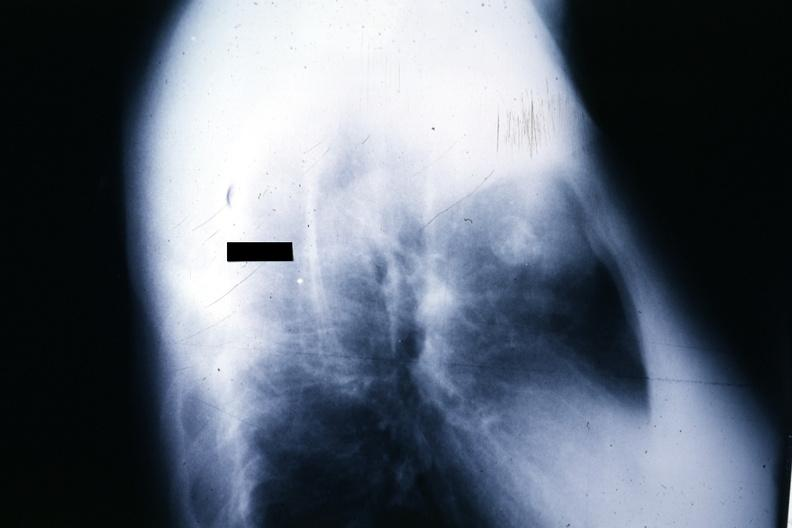what is present?
Answer the question using a single word or phrase. Thymus 